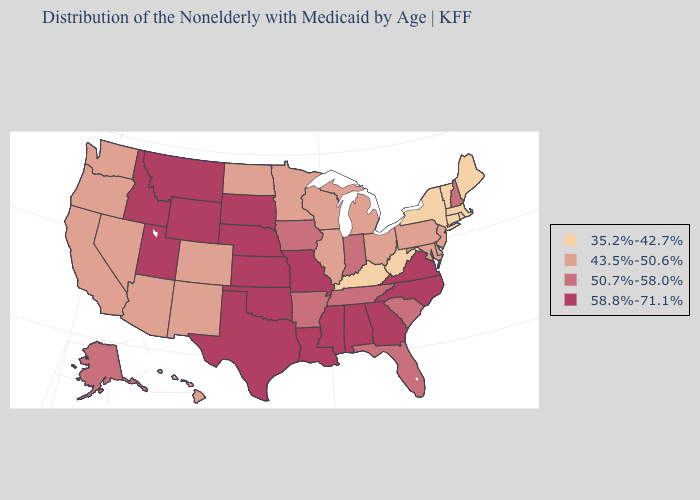Is the legend a continuous bar?
Concise answer only. No. Name the states that have a value in the range 58.8%-71.1%?
Concise answer only. Alabama, Georgia, Idaho, Kansas, Louisiana, Mississippi, Missouri, Montana, Nebraska, North Carolina, Oklahoma, South Dakota, Texas, Utah, Virginia, Wyoming. Name the states that have a value in the range 43.5%-50.6%?
Keep it brief. Arizona, California, Colorado, Delaware, Hawaii, Illinois, Maryland, Michigan, Minnesota, Nevada, New Jersey, New Mexico, North Dakota, Ohio, Oregon, Pennsylvania, Washington, Wisconsin. Name the states that have a value in the range 50.7%-58.0%?
Keep it brief. Alaska, Arkansas, Florida, Indiana, Iowa, New Hampshire, South Carolina, Tennessee. Name the states that have a value in the range 43.5%-50.6%?
Be succinct. Arizona, California, Colorado, Delaware, Hawaii, Illinois, Maryland, Michigan, Minnesota, Nevada, New Jersey, New Mexico, North Dakota, Ohio, Oregon, Pennsylvania, Washington, Wisconsin. Among the states that border North Dakota , does Montana have the highest value?
Keep it brief. Yes. What is the lowest value in the South?
Give a very brief answer. 35.2%-42.7%. What is the value of Kansas?
Be succinct. 58.8%-71.1%. Does Minnesota have a higher value than Nebraska?
Keep it brief. No. Which states have the lowest value in the West?
Give a very brief answer. Arizona, California, Colorado, Hawaii, Nevada, New Mexico, Oregon, Washington. Name the states that have a value in the range 43.5%-50.6%?
Quick response, please. Arizona, California, Colorado, Delaware, Hawaii, Illinois, Maryland, Michigan, Minnesota, Nevada, New Jersey, New Mexico, North Dakota, Ohio, Oregon, Pennsylvania, Washington, Wisconsin. Name the states that have a value in the range 43.5%-50.6%?
Write a very short answer. Arizona, California, Colorado, Delaware, Hawaii, Illinois, Maryland, Michigan, Minnesota, Nevada, New Jersey, New Mexico, North Dakota, Ohio, Oregon, Pennsylvania, Washington, Wisconsin. Does Idaho have the highest value in the West?
Concise answer only. Yes. What is the lowest value in the West?
Keep it brief. 43.5%-50.6%. 